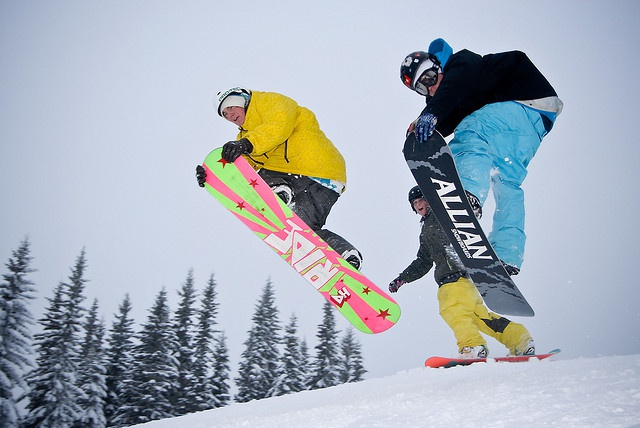Describe the objects in this image and their specific colors. I can see people in darkgray, black, lightblue, lavender, and teal tones, people in darkgray, gold, black, and gray tones, snowboard in darkgray, lightpink, lightgreen, and lightgray tones, snowboard in darkgray, black, gray, and lightgray tones, and people in darkgray, black, khaki, tan, and gray tones in this image. 